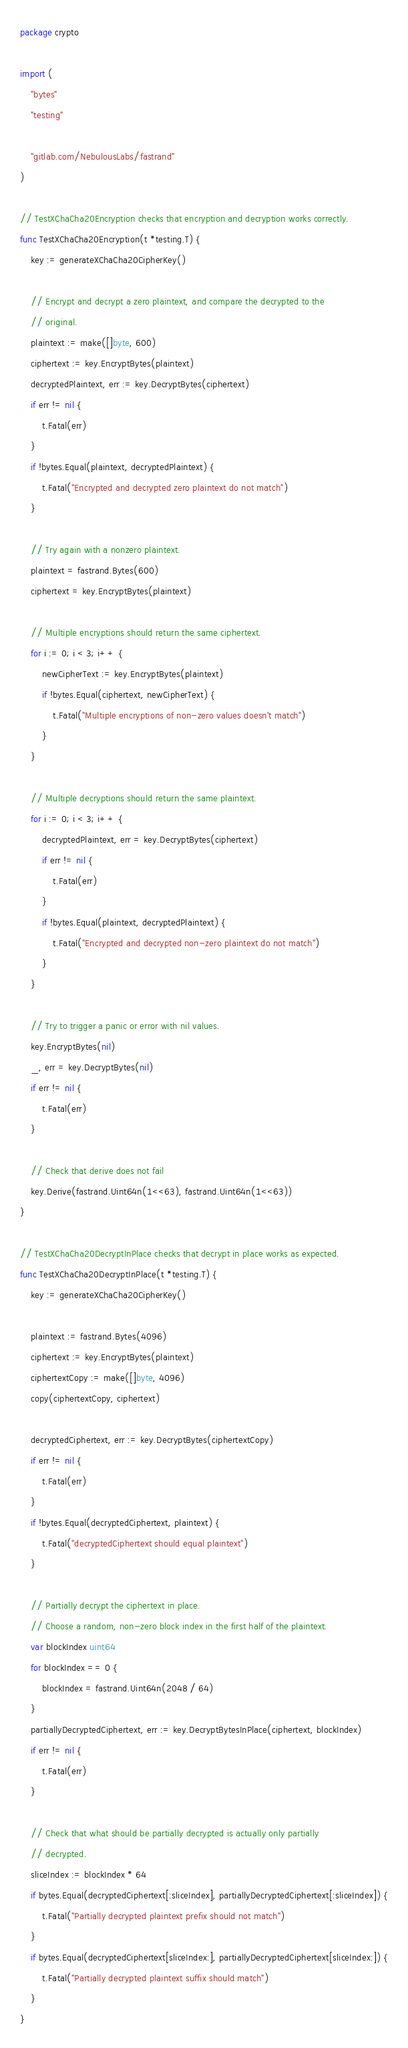<code> <loc_0><loc_0><loc_500><loc_500><_Go_>package crypto

import (
	"bytes"
	"testing"

	"gitlab.com/NebulousLabs/fastrand"
)

// TestXChaCha20Encryption checks that encryption and decryption works correctly.
func TestXChaCha20Encryption(t *testing.T) {
	key := generateXChaCha20CipherKey()

	// Encrypt and decrypt a zero plaintext, and compare the decrypted to the
	// original.
	plaintext := make([]byte, 600)
	ciphertext := key.EncryptBytes(plaintext)
	decryptedPlaintext, err := key.DecryptBytes(ciphertext)
	if err != nil {
		t.Fatal(err)
	}
	if !bytes.Equal(plaintext, decryptedPlaintext) {
		t.Fatal("Encrypted and decrypted zero plaintext do not match")
	}

	// Try again with a nonzero plaintext.
	plaintext = fastrand.Bytes(600)
	ciphertext = key.EncryptBytes(plaintext)

	// Multiple encryptions should return the same ciphertext.
	for i := 0; i < 3; i++ {
		newCipherText := key.EncryptBytes(plaintext)
		if !bytes.Equal(ciphertext, newCipherText) {
			t.Fatal("Multiple encryptions of non-zero values doesn't match")
		}
	}

	// Multiple decryptions should return the same plaintext.
	for i := 0; i < 3; i++ {
		decryptedPlaintext, err = key.DecryptBytes(ciphertext)
		if err != nil {
			t.Fatal(err)
		}
		if !bytes.Equal(plaintext, decryptedPlaintext) {
			t.Fatal("Encrypted and decrypted non-zero plaintext do not match")
		}
	}

	// Try to trigger a panic or error with nil values.
	key.EncryptBytes(nil)
	_, err = key.DecryptBytes(nil)
	if err != nil {
		t.Fatal(err)
	}

	// Check that derive does not fail
	key.Derive(fastrand.Uint64n(1<<63), fastrand.Uint64n(1<<63))
}

// TestXChaCha20DecryptInPlace checks that decrypt in place works as expected.
func TestXChaCha20DecryptInPlace(t *testing.T) {
	key := generateXChaCha20CipherKey()

	plaintext := fastrand.Bytes(4096)
	ciphertext := key.EncryptBytes(plaintext)
	ciphertextCopy := make([]byte, 4096)
	copy(ciphertextCopy, ciphertext)

	decryptedCiphertext, err := key.DecryptBytes(ciphertextCopy)
	if err != nil {
		t.Fatal(err)
	}
	if !bytes.Equal(decryptedCiphertext, plaintext) {
		t.Fatal("decryptedCiphertext should equal plaintext")
	}

	// Partially decrypt the ciphertext in place.
	// Choose a random, non-zero block index in the first half of the plaintext.
	var blockIndex uint64
	for blockIndex == 0 {
		blockIndex = fastrand.Uint64n(2048 / 64)
	}
	partiallyDecryptedCiphertext, err := key.DecryptBytesInPlace(ciphertext, blockIndex)
	if err != nil {
		t.Fatal(err)
	}

	// Check that what should be partially decrypted is actually only partially
	// decrypted.
	sliceIndex := blockIndex * 64
	if bytes.Equal(decryptedCiphertext[:sliceIndex], partiallyDecryptedCiphertext[:sliceIndex]) {
		t.Fatal("Partially decrypted plaintext prefix should not match")
	}
	if bytes.Equal(decryptedCiphertext[sliceIndex:], partiallyDecryptedCiphertext[sliceIndex:]) {
		t.Fatal("Partially decrypted plaintext suffix should match")
	}
}
</code> 